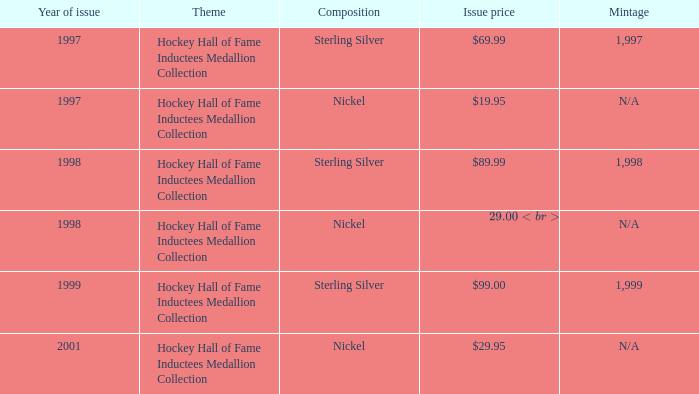Which work is priced at $99.00 with an issue? Sterling Silver. 